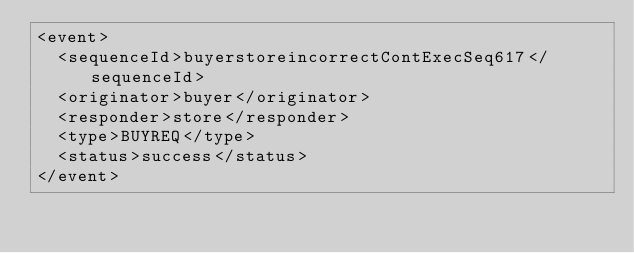<code> <loc_0><loc_0><loc_500><loc_500><_XML_><event>
  <sequenceId>buyerstoreincorrectContExecSeq617</sequenceId>
  <originator>buyer</originator>
  <responder>store</responder>
  <type>BUYREQ</type>
  <status>success</status>
</event>
</code> 